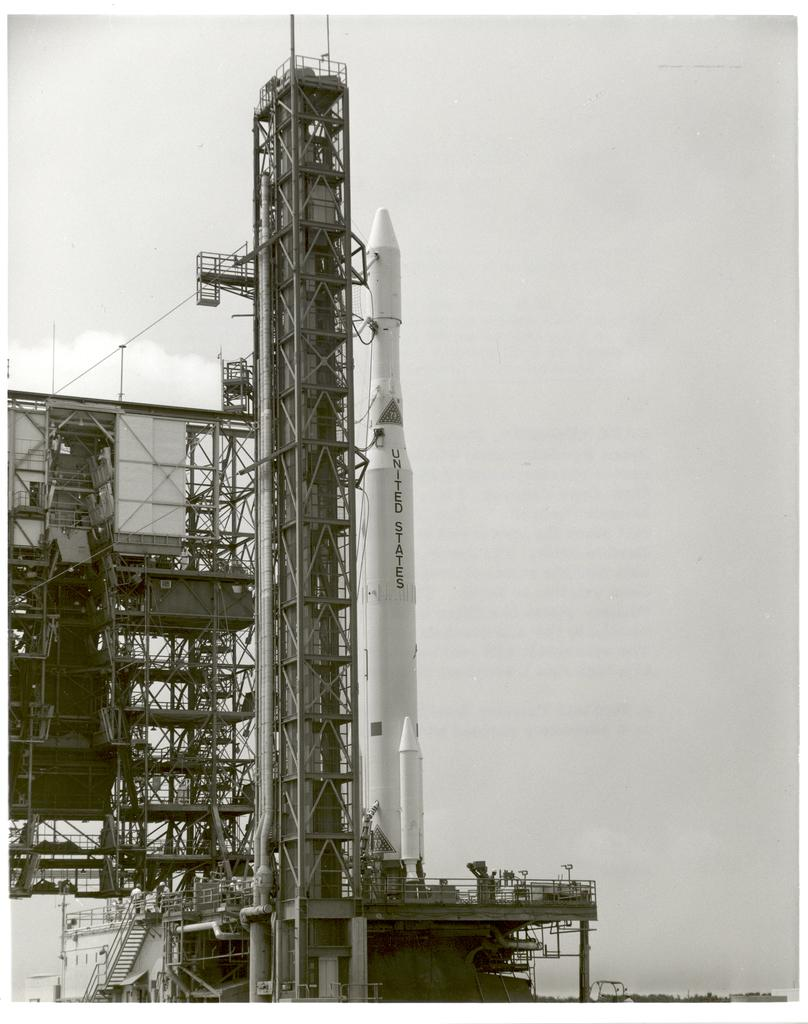What is the main subject in the center of the image? There is a rocket in the center of the image. What are the ropes visible in the image used for? The purpose of the ropes visible in the image cannot be determined from the provided facts. What type of structure is present in the image? There is a building in the image. Are there any other objects visible in the image? Yes, there are a few other objects in the image. What type of cart is used to transport the rocket in the image? There is no cart present in the image; the rocket is not being transported. What kind of pain is the person in the image experiencing? There is no person present in the image, so it is not possible to determine if anyone is experiencing pain. 